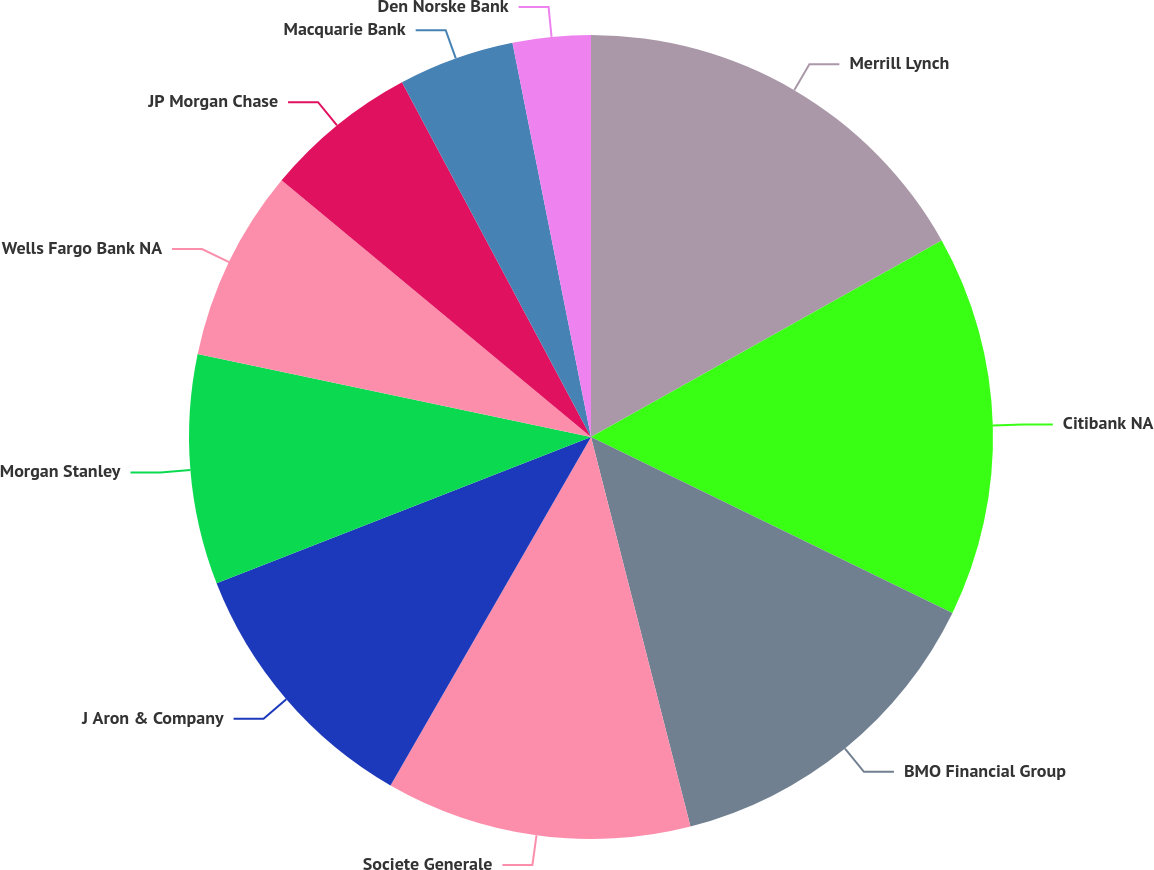Convert chart to OTSL. <chart><loc_0><loc_0><loc_500><loc_500><pie_chart><fcel>Merrill Lynch<fcel>Citibank NA<fcel>BMO Financial Group<fcel>Societe Generale<fcel>J Aron & Company<fcel>Morgan Stanley<fcel>Wells Fargo Bank NA<fcel>JP Morgan Chase<fcel>Macquarie Bank<fcel>Den Norske Bank<nl><fcel>16.87%<fcel>15.34%<fcel>13.81%<fcel>12.29%<fcel>10.76%<fcel>9.24%<fcel>7.71%<fcel>6.19%<fcel>4.66%<fcel>3.13%<nl></chart> 